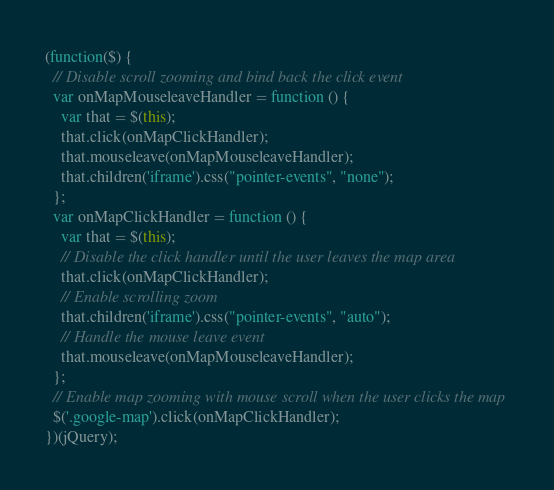<code> <loc_0><loc_0><loc_500><loc_500><_JavaScript_>(function($) {
  // Disable scroll zooming and bind back the click event
  var onMapMouseleaveHandler = function () {
    var that = $(this);
    that.click(onMapClickHandler);
    that.mouseleave(onMapMouseleaveHandler);
    that.children('iframe').css("pointer-events", "none");
  };
  var onMapClickHandler = function () {
    var that = $(this);
    // Disable the click handler until the user leaves the map area
    that.click(onMapClickHandler);
    // Enable scrolling zoom
    that.children('iframe').css("pointer-events", "auto");
    // Handle the mouse leave event
    that.mouseleave(onMapMouseleaveHandler);
  };
  // Enable map zooming with mouse scroll when the user clicks the map
  $('.google-map').click(onMapClickHandler);
})(jQuery);
</code> 